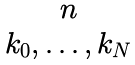Convert formula to latex. <formula><loc_0><loc_0><loc_500><loc_500>\begin{matrix} n \\ k _ { 0 } , \dots , k _ { N } \end{matrix}</formula> 